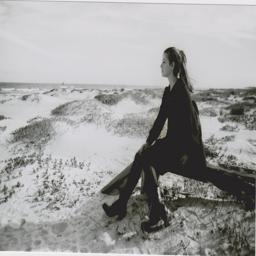How does the presence of the individual impact the interpretation of this scene? The presence of the individual sitting contemplatively in the dunes adds a human element to the natural scene, invoking themes of solitude and introspection. It suggests a harmonious interaction between humans and nature, possibly conveying a narrative of seeking peace or a personal connection with the environment. 